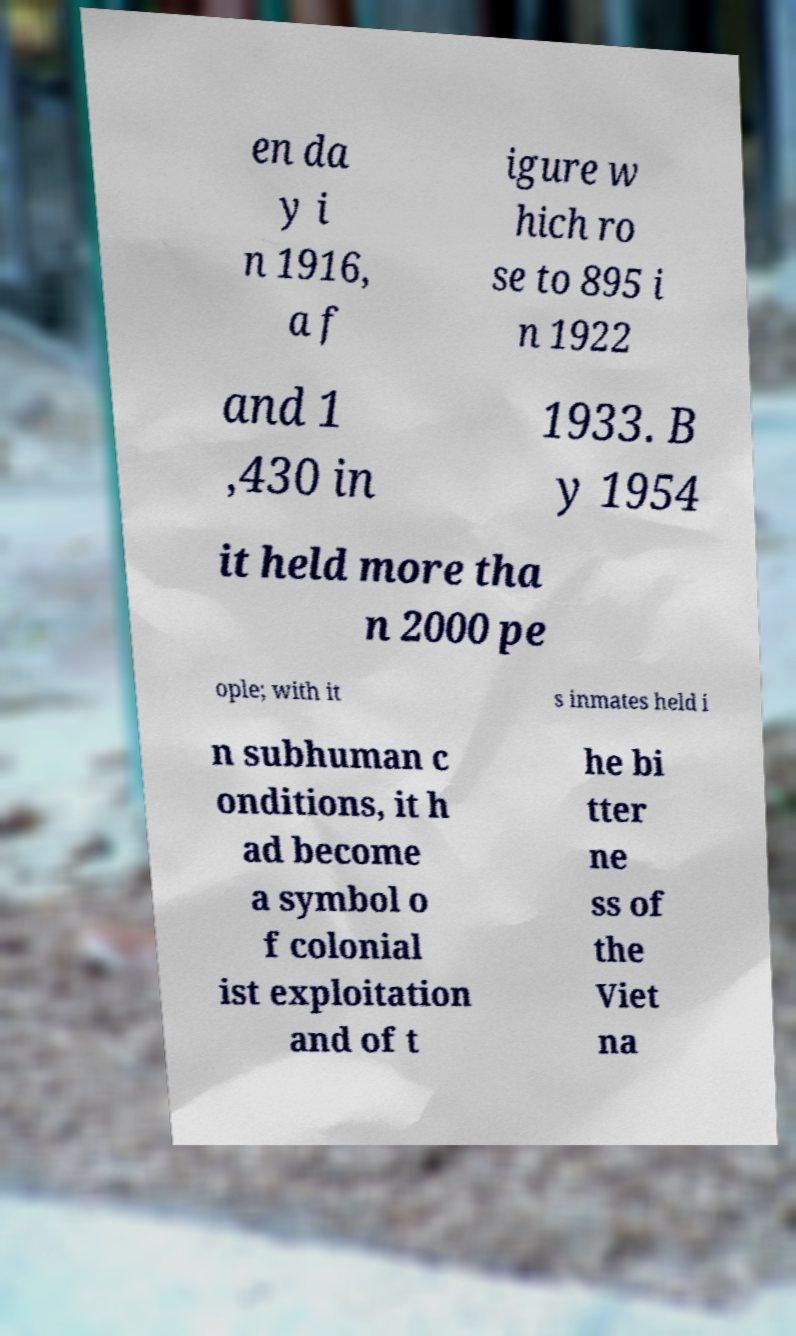Can you read and provide the text displayed in the image?This photo seems to have some interesting text. Can you extract and type it out for me? en da y i n 1916, a f igure w hich ro se to 895 i n 1922 and 1 ,430 in 1933. B y 1954 it held more tha n 2000 pe ople; with it s inmates held i n subhuman c onditions, it h ad become a symbol o f colonial ist exploitation and of t he bi tter ne ss of the Viet na 